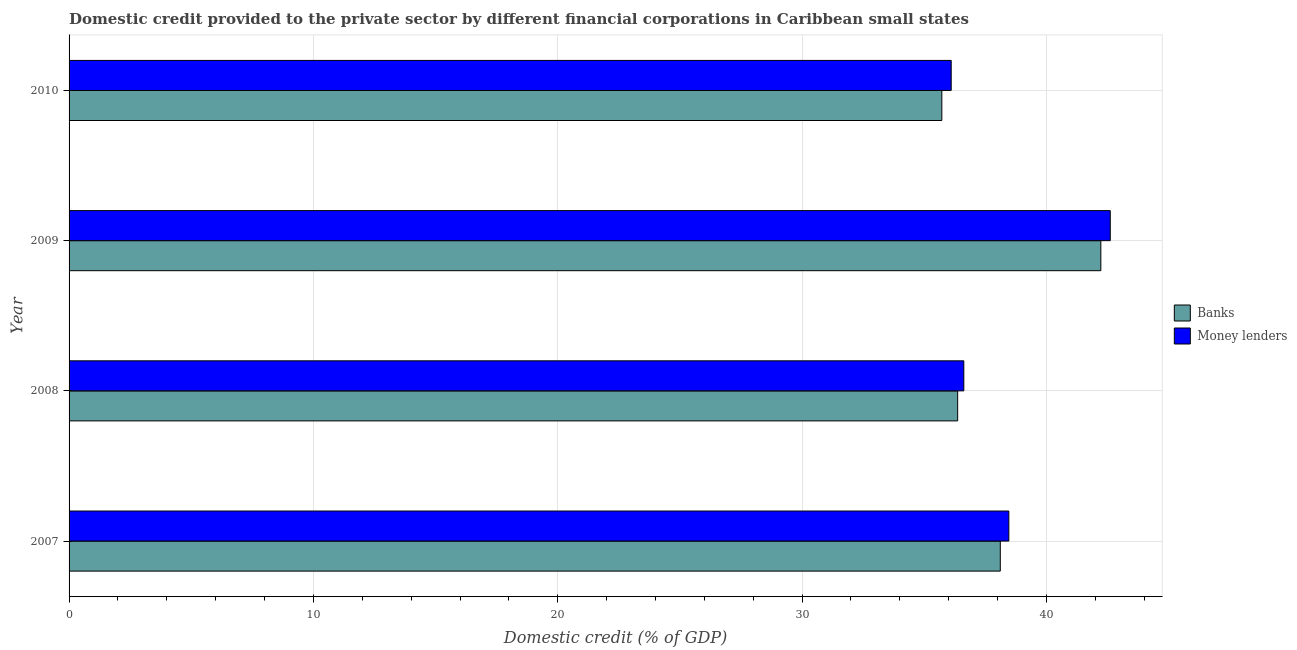How many groups of bars are there?
Your answer should be very brief. 4. Are the number of bars per tick equal to the number of legend labels?
Provide a short and direct response. Yes. Are the number of bars on each tick of the Y-axis equal?
Give a very brief answer. Yes. How many bars are there on the 4th tick from the bottom?
Your response must be concise. 2. What is the domestic credit provided by money lenders in 2010?
Ensure brevity in your answer.  36.1. Across all years, what is the maximum domestic credit provided by money lenders?
Your answer should be very brief. 42.61. Across all years, what is the minimum domestic credit provided by banks?
Keep it short and to the point. 35.72. In which year was the domestic credit provided by money lenders minimum?
Provide a short and direct response. 2010. What is the total domestic credit provided by money lenders in the graph?
Offer a very short reply. 153.8. What is the difference between the domestic credit provided by money lenders in 2007 and that in 2010?
Ensure brevity in your answer.  2.36. What is the difference between the domestic credit provided by banks in 2008 and the domestic credit provided by money lenders in 2007?
Your answer should be very brief. -2.1. What is the average domestic credit provided by money lenders per year?
Give a very brief answer. 38.45. In the year 2008, what is the difference between the domestic credit provided by money lenders and domestic credit provided by banks?
Provide a succinct answer. 0.25. What is the ratio of the domestic credit provided by money lenders in 2007 to that in 2008?
Provide a short and direct response. 1.05. Is the difference between the domestic credit provided by banks in 2008 and 2010 greater than the difference between the domestic credit provided by money lenders in 2008 and 2010?
Make the answer very short. Yes. What is the difference between the highest and the second highest domestic credit provided by money lenders?
Ensure brevity in your answer.  4.15. What is the difference between the highest and the lowest domestic credit provided by money lenders?
Provide a short and direct response. 6.51. What does the 1st bar from the top in 2007 represents?
Give a very brief answer. Money lenders. What does the 1st bar from the bottom in 2007 represents?
Keep it short and to the point. Banks. How many bars are there?
Offer a terse response. 8. How many years are there in the graph?
Your answer should be very brief. 4. Are the values on the major ticks of X-axis written in scientific E-notation?
Your response must be concise. No. Does the graph contain any zero values?
Keep it short and to the point. No. How many legend labels are there?
Give a very brief answer. 2. What is the title of the graph?
Your response must be concise. Domestic credit provided to the private sector by different financial corporations in Caribbean small states. Does "DAC donors" appear as one of the legend labels in the graph?
Your response must be concise. No. What is the label or title of the X-axis?
Keep it short and to the point. Domestic credit (% of GDP). What is the label or title of the Y-axis?
Your response must be concise. Year. What is the Domestic credit (% of GDP) in Banks in 2007?
Give a very brief answer. 38.11. What is the Domestic credit (% of GDP) of Money lenders in 2007?
Give a very brief answer. 38.46. What is the Domestic credit (% of GDP) of Banks in 2008?
Your response must be concise. 36.37. What is the Domestic credit (% of GDP) of Money lenders in 2008?
Keep it short and to the point. 36.62. What is the Domestic credit (% of GDP) of Banks in 2009?
Provide a succinct answer. 42.23. What is the Domestic credit (% of GDP) in Money lenders in 2009?
Your answer should be compact. 42.61. What is the Domestic credit (% of GDP) of Banks in 2010?
Your answer should be very brief. 35.72. What is the Domestic credit (% of GDP) of Money lenders in 2010?
Offer a very short reply. 36.1. Across all years, what is the maximum Domestic credit (% of GDP) of Banks?
Offer a terse response. 42.23. Across all years, what is the maximum Domestic credit (% of GDP) of Money lenders?
Offer a very short reply. 42.61. Across all years, what is the minimum Domestic credit (% of GDP) of Banks?
Offer a very short reply. 35.72. Across all years, what is the minimum Domestic credit (% of GDP) in Money lenders?
Offer a terse response. 36.1. What is the total Domestic credit (% of GDP) of Banks in the graph?
Your response must be concise. 152.43. What is the total Domestic credit (% of GDP) in Money lenders in the graph?
Offer a very short reply. 153.8. What is the difference between the Domestic credit (% of GDP) of Banks in 2007 and that in 2008?
Provide a succinct answer. 1.75. What is the difference between the Domestic credit (% of GDP) of Money lenders in 2007 and that in 2008?
Offer a very short reply. 1.84. What is the difference between the Domestic credit (% of GDP) of Banks in 2007 and that in 2009?
Keep it short and to the point. -4.12. What is the difference between the Domestic credit (% of GDP) of Money lenders in 2007 and that in 2009?
Offer a terse response. -4.15. What is the difference between the Domestic credit (% of GDP) in Banks in 2007 and that in 2010?
Provide a succinct answer. 2.39. What is the difference between the Domestic credit (% of GDP) in Money lenders in 2007 and that in 2010?
Keep it short and to the point. 2.36. What is the difference between the Domestic credit (% of GDP) of Banks in 2008 and that in 2009?
Your answer should be very brief. -5.86. What is the difference between the Domestic credit (% of GDP) of Money lenders in 2008 and that in 2009?
Offer a terse response. -5.99. What is the difference between the Domestic credit (% of GDP) of Banks in 2008 and that in 2010?
Keep it short and to the point. 0.65. What is the difference between the Domestic credit (% of GDP) of Money lenders in 2008 and that in 2010?
Your answer should be compact. 0.52. What is the difference between the Domestic credit (% of GDP) of Banks in 2009 and that in 2010?
Keep it short and to the point. 6.51. What is the difference between the Domestic credit (% of GDP) in Money lenders in 2009 and that in 2010?
Offer a very short reply. 6.51. What is the difference between the Domestic credit (% of GDP) in Banks in 2007 and the Domestic credit (% of GDP) in Money lenders in 2008?
Provide a short and direct response. 1.49. What is the difference between the Domestic credit (% of GDP) of Banks in 2007 and the Domestic credit (% of GDP) of Money lenders in 2009?
Offer a very short reply. -4.5. What is the difference between the Domestic credit (% of GDP) of Banks in 2007 and the Domestic credit (% of GDP) of Money lenders in 2010?
Your answer should be compact. 2.01. What is the difference between the Domestic credit (% of GDP) in Banks in 2008 and the Domestic credit (% of GDP) in Money lenders in 2009?
Offer a terse response. -6.25. What is the difference between the Domestic credit (% of GDP) of Banks in 2008 and the Domestic credit (% of GDP) of Money lenders in 2010?
Give a very brief answer. 0.26. What is the difference between the Domestic credit (% of GDP) of Banks in 2009 and the Domestic credit (% of GDP) of Money lenders in 2010?
Provide a succinct answer. 6.12. What is the average Domestic credit (% of GDP) of Banks per year?
Offer a very short reply. 38.11. What is the average Domestic credit (% of GDP) of Money lenders per year?
Your answer should be compact. 38.45. In the year 2007, what is the difference between the Domestic credit (% of GDP) of Banks and Domestic credit (% of GDP) of Money lenders?
Offer a terse response. -0.35. In the year 2008, what is the difference between the Domestic credit (% of GDP) of Banks and Domestic credit (% of GDP) of Money lenders?
Offer a very short reply. -0.25. In the year 2009, what is the difference between the Domestic credit (% of GDP) in Banks and Domestic credit (% of GDP) in Money lenders?
Make the answer very short. -0.38. In the year 2010, what is the difference between the Domestic credit (% of GDP) in Banks and Domestic credit (% of GDP) in Money lenders?
Your response must be concise. -0.38. What is the ratio of the Domestic credit (% of GDP) of Banks in 2007 to that in 2008?
Ensure brevity in your answer.  1.05. What is the ratio of the Domestic credit (% of GDP) of Money lenders in 2007 to that in 2008?
Keep it short and to the point. 1.05. What is the ratio of the Domestic credit (% of GDP) in Banks in 2007 to that in 2009?
Provide a succinct answer. 0.9. What is the ratio of the Domestic credit (% of GDP) in Money lenders in 2007 to that in 2009?
Provide a short and direct response. 0.9. What is the ratio of the Domestic credit (% of GDP) in Banks in 2007 to that in 2010?
Your answer should be compact. 1.07. What is the ratio of the Domestic credit (% of GDP) of Money lenders in 2007 to that in 2010?
Keep it short and to the point. 1.07. What is the ratio of the Domestic credit (% of GDP) in Banks in 2008 to that in 2009?
Your answer should be compact. 0.86. What is the ratio of the Domestic credit (% of GDP) in Money lenders in 2008 to that in 2009?
Your response must be concise. 0.86. What is the ratio of the Domestic credit (% of GDP) in Banks in 2008 to that in 2010?
Offer a terse response. 1.02. What is the ratio of the Domestic credit (% of GDP) of Money lenders in 2008 to that in 2010?
Ensure brevity in your answer.  1.01. What is the ratio of the Domestic credit (% of GDP) of Banks in 2009 to that in 2010?
Offer a terse response. 1.18. What is the ratio of the Domestic credit (% of GDP) of Money lenders in 2009 to that in 2010?
Ensure brevity in your answer.  1.18. What is the difference between the highest and the second highest Domestic credit (% of GDP) of Banks?
Make the answer very short. 4.12. What is the difference between the highest and the second highest Domestic credit (% of GDP) of Money lenders?
Keep it short and to the point. 4.15. What is the difference between the highest and the lowest Domestic credit (% of GDP) in Banks?
Your answer should be very brief. 6.51. What is the difference between the highest and the lowest Domestic credit (% of GDP) in Money lenders?
Make the answer very short. 6.51. 